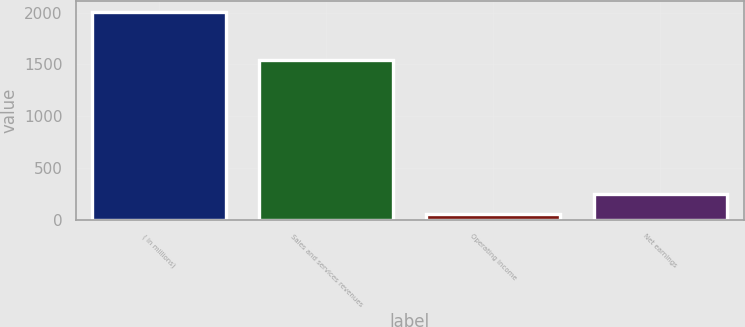<chart> <loc_0><loc_0><loc_500><loc_500><bar_chart><fcel>( in millions)<fcel>Sales and services revenues<fcel>Operating income<fcel>Net earnings<nl><fcel>2010<fcel>1547<fcel>59<fcel>254.1<nl></chart> 